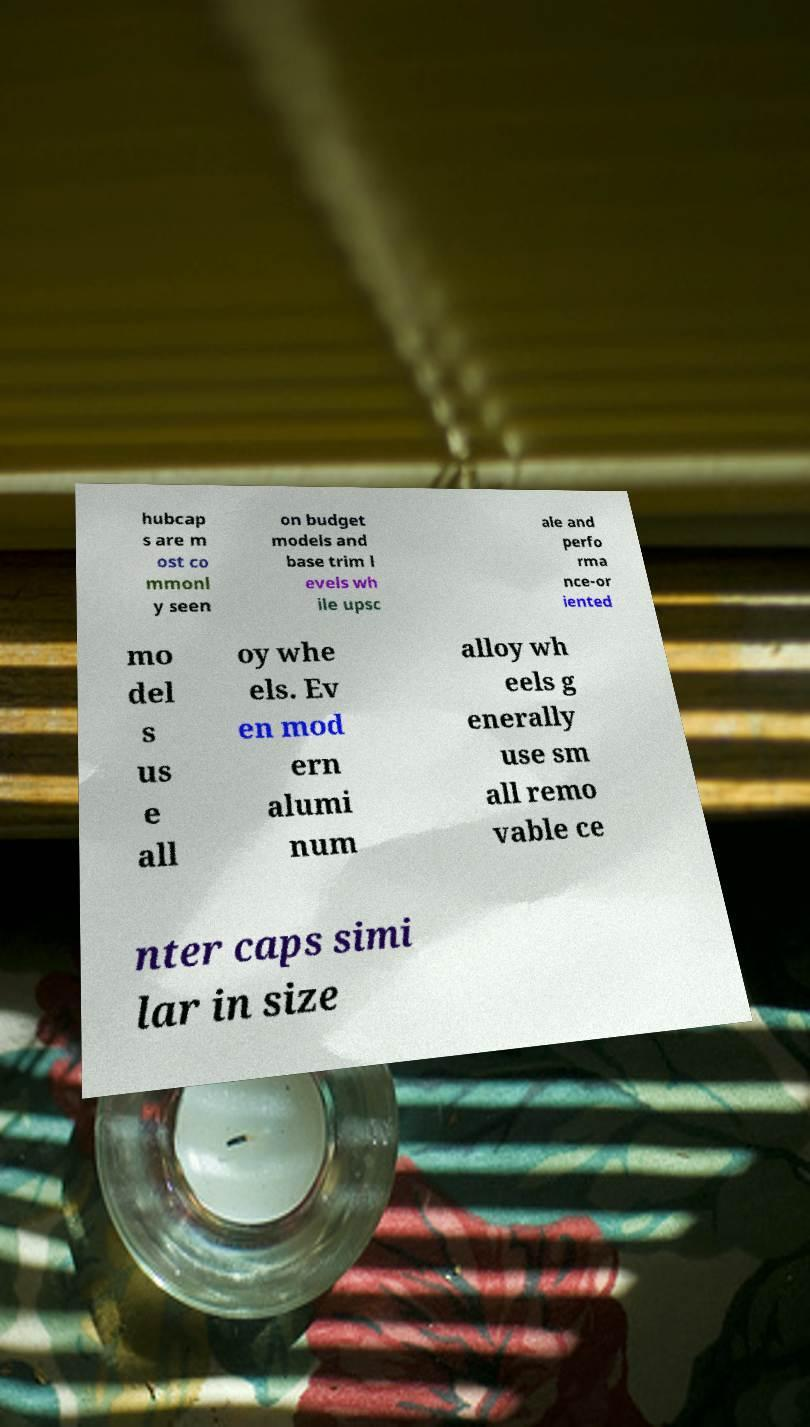Could you extract and type out the text from this image? hubcap s are m ost co mmonl y seen on budget models and base trim l evels wh ile upsc ale and perfo rma nce-or iented mo del s us e all oy whe els. Ev en mod ern alumi num alloy wh eels g enerally use sm all remo vable ce nter caps simi lar in size 